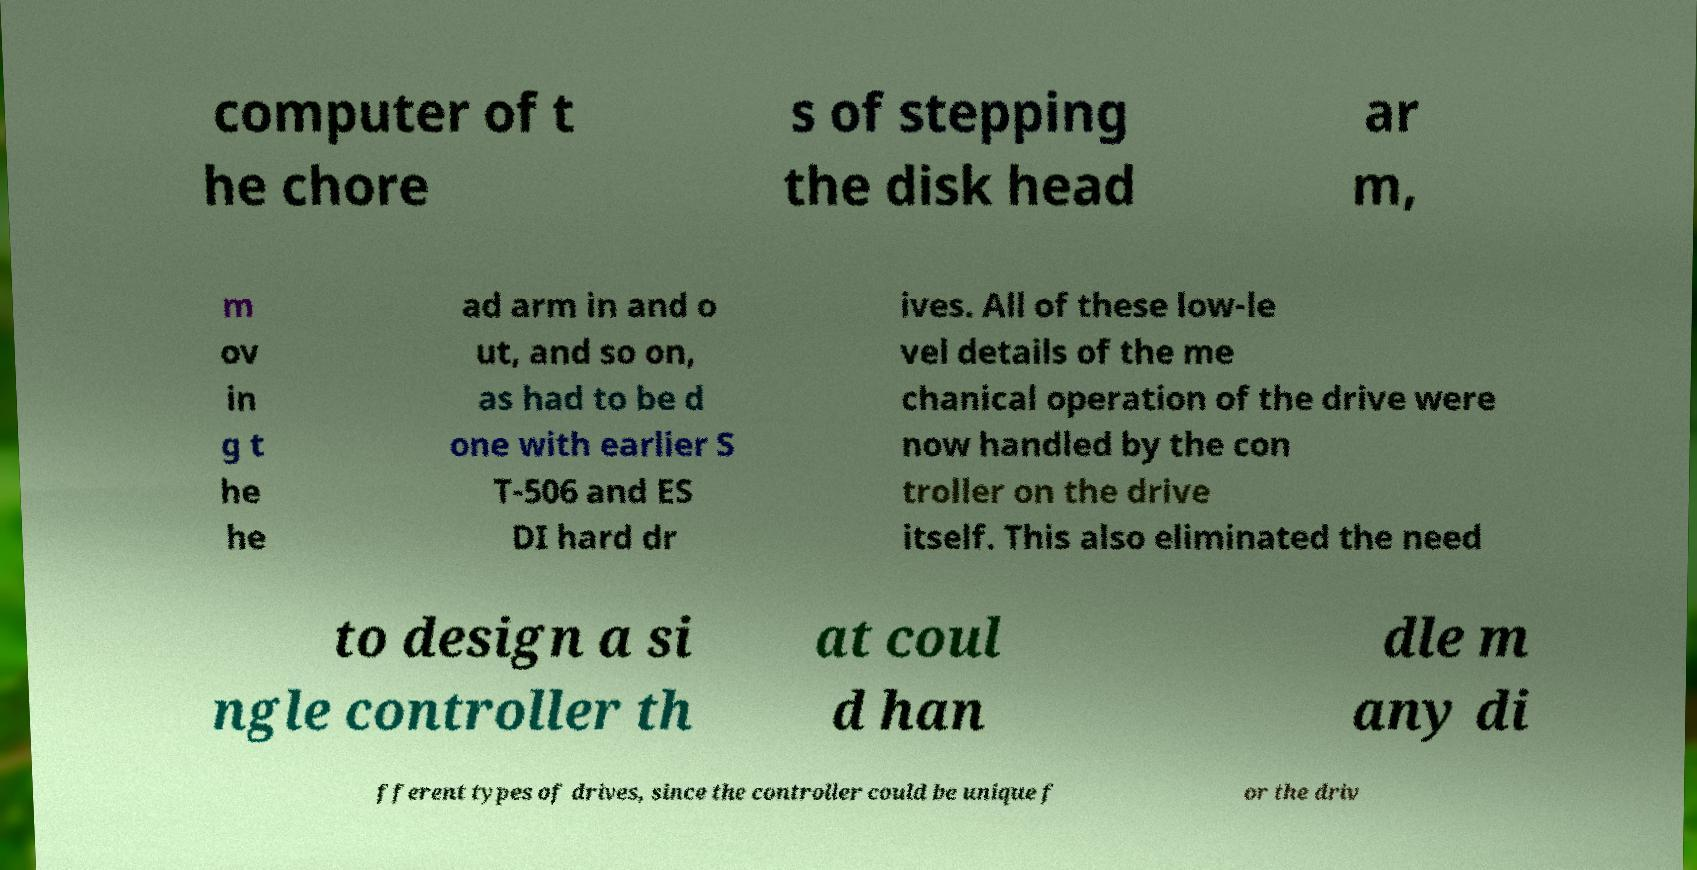Please read and relay the text visible in this image. What does it say? computer of t he chore s of stepping the disk head ar m, m ov in g t he he ad arm in and o ut, and so on, as had to be d one with earlier S T-506 and ES DI hard dr ives. All of these low-le vel details of the me chanical operation of the drive were now handled by the con troller on the drive itself. This also eliminated the need to design a si ngle controller th at coul d han dle m any di fferent types of drives, since the controller could be unique f or the driv 